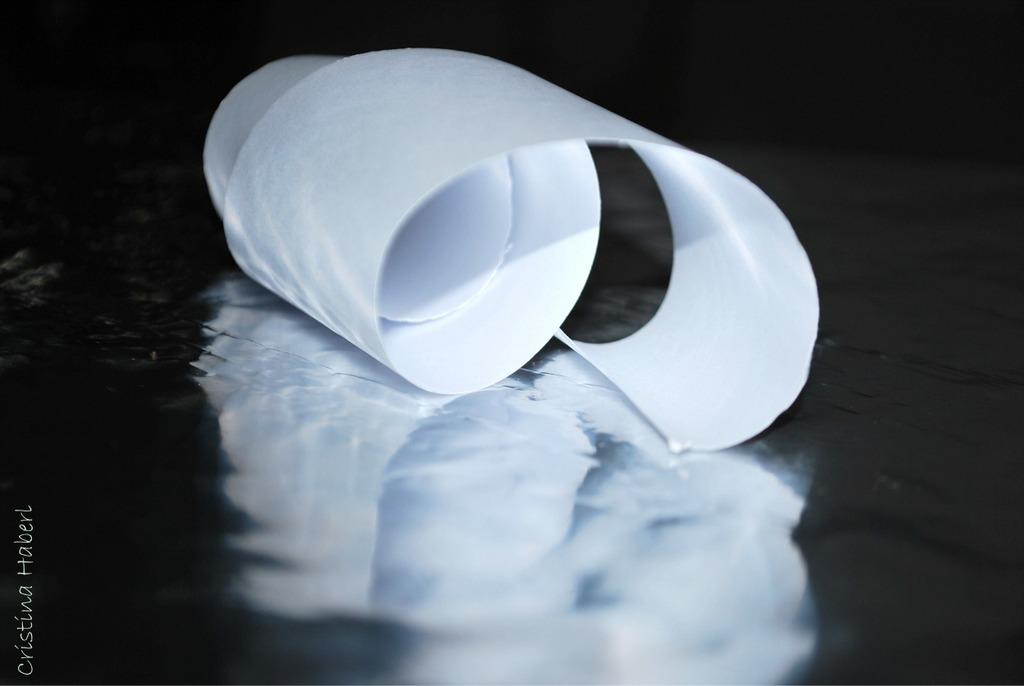What is the main object in the image? There is a paper roll in the image. What is the color of the surface on which the paper roll is placed? The paper roll is on a black color surface. What type of collar can be seen on the paper roll in the image? There is no collar present on the paper roll in the image, as it is an inanimate object. 